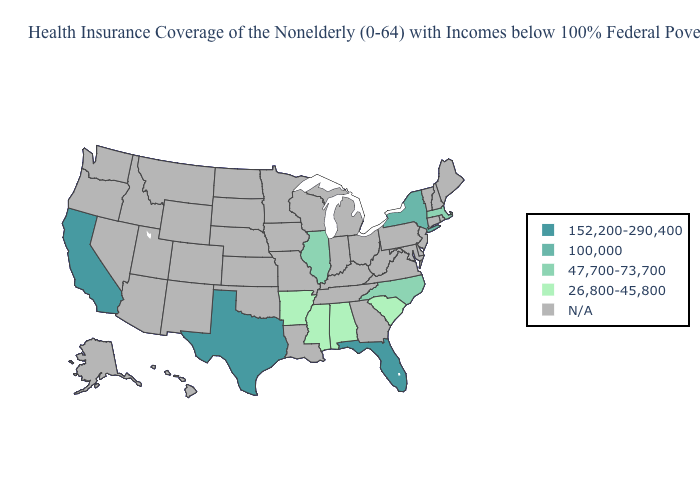Does the map have missing data?
Quick response, please. Yes. Which states have the lowest value in the MidWest?
Short answer required. Illinois. How many symbols are there in the legend?
Concise answer only. 5. Does New York have the lowest value in the Northeast?
Be succinct. No. Does Illinois have the highest value in the USA?
Quick response, please. No. Is the legend a continuous bar?
Keep it brief. No. Among the states that border Louisiana , does Texas have the highest value?
Give a very brief answer. Yes. What is the highest value in the USA?
Be succinct. 152,200-290,400. What is the lowest value in the USA?
Answer briefly. 26,800-45,800. Which states hav the highest value in the MidWest?
Quick response, please. Illinois. What is the lowest value in the MidWest?
Answer briefly. 47,700-73,700. What is the value of Mississippi?
Concise answer only. 26,800-45,800. What is the value of Maine?
Be succinct. N/A. 